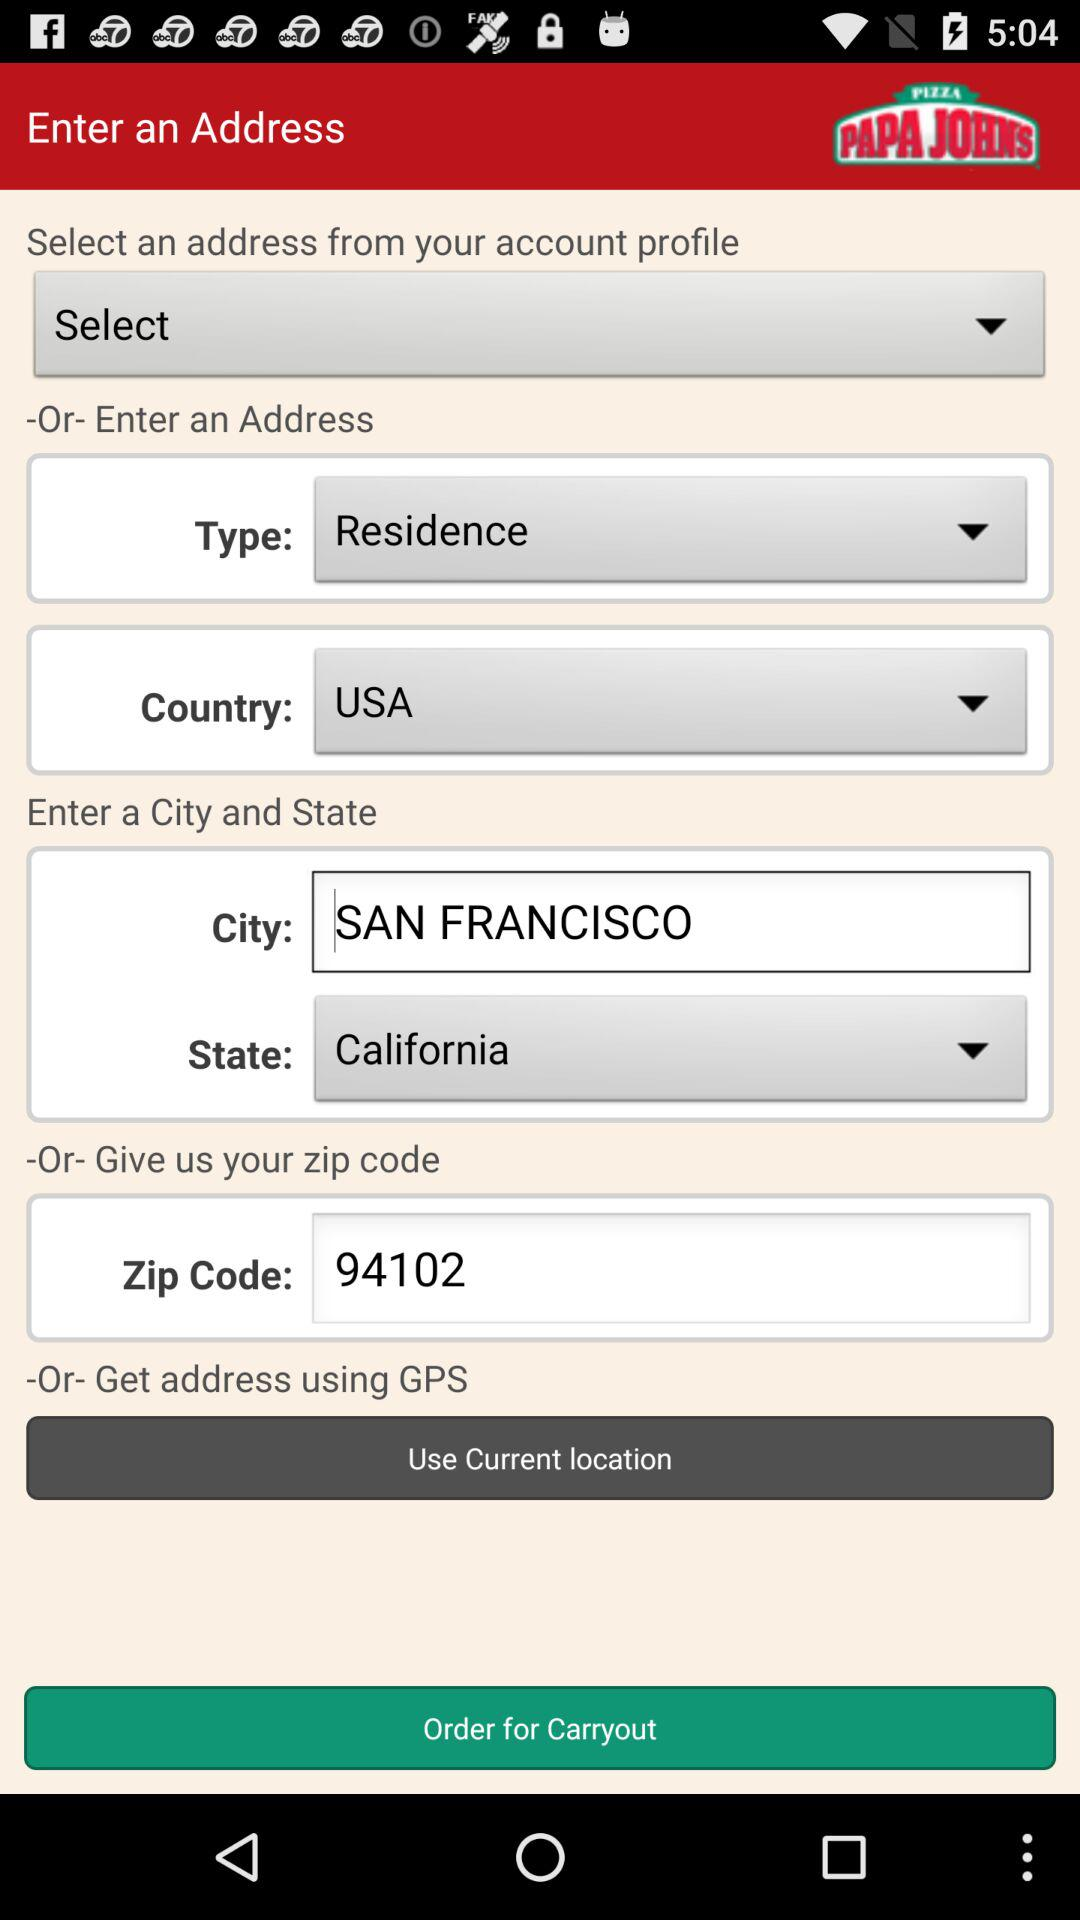Which state is mentioned? The state is California. 